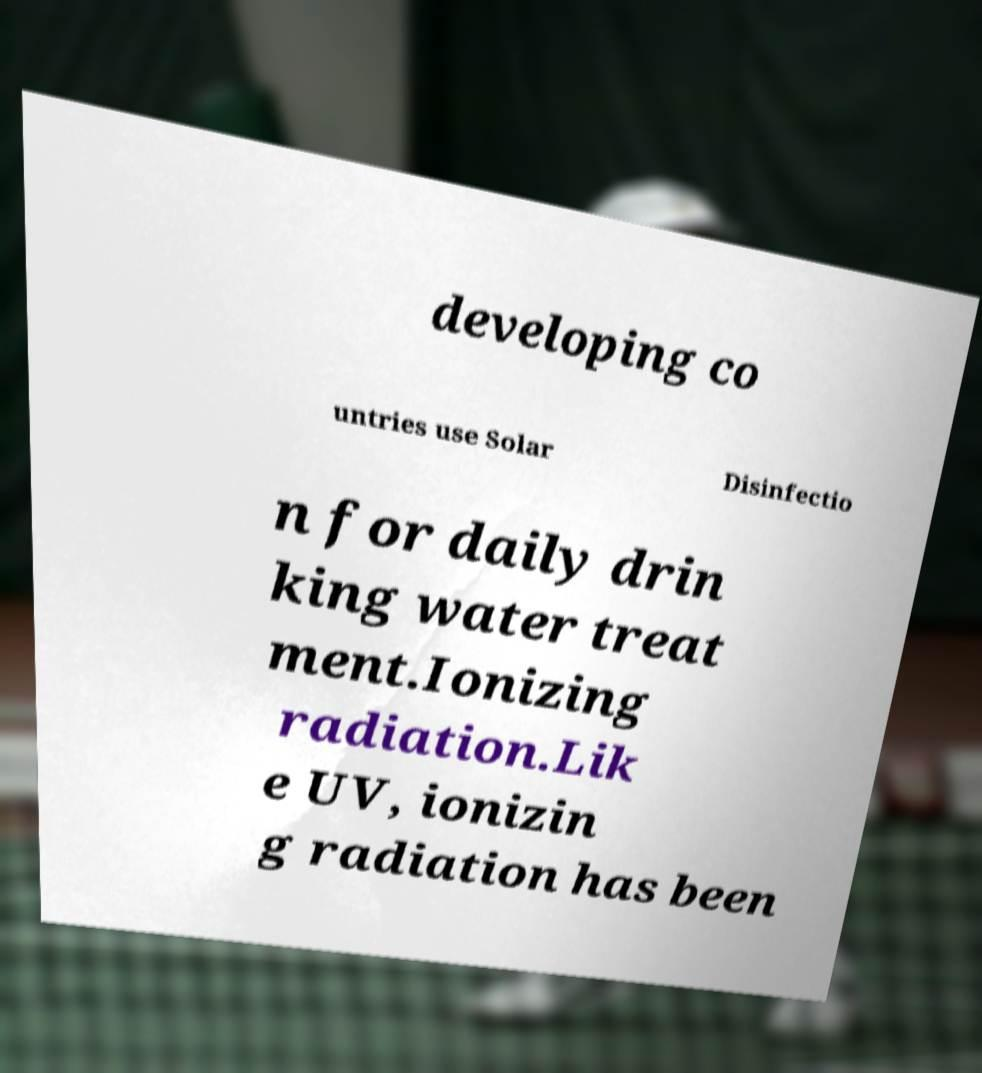Could you extract and type out the text from this image? developing co untries use Solar Disinfectio n for daily drin king water treat ment.Ionizing radiation.Lik e UV, ionizin g radiation has been 